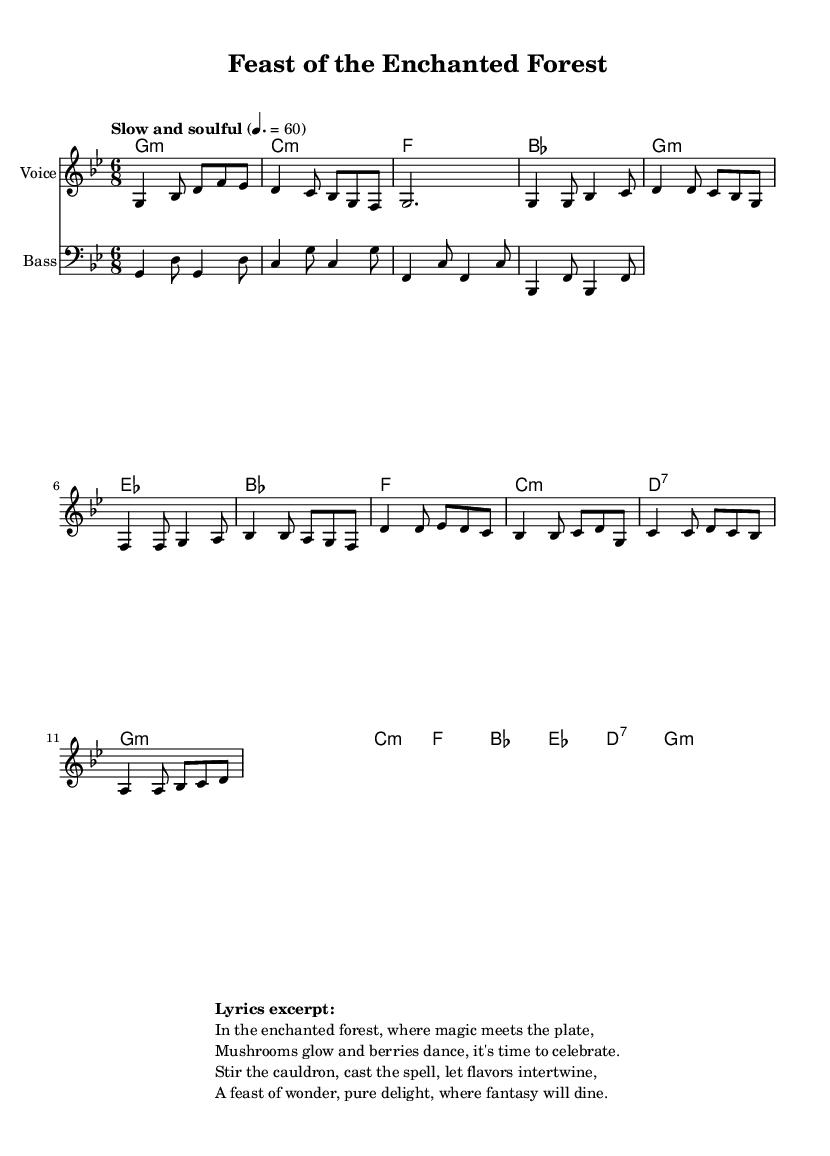What is the key signature of this music? The key signature is G minor, which typically has two flats (B-flat and E-flat) indicated at the beginning of the staff.
Answer: G minor What is the time signature of this music? The time signature is 6/8, as indicated at the beginning of the score, which denotes six eighth notes per measure.
Answer: 6/8 What is the tempo marking for this piece? The tempo marking states "Slow and soulful" with a metronome indication of 60 beats per minute, indicating a slow and smooth performance style.
Answer: Slow and soulful How many main sections can be identified in this ballad? The ballad contains three main sections: the Intro, Verse, and Chorus, as outlined in the structure of the score.
Answer: Three What is the overall theme of the lyrics in this soul ballad? The theme revolves around an enchanted forest where magical feasts take place, celebrating the intertwining of flavors and fantasy.
Answer: Enchanted feast Describe the type of harmony used in this piece during the chorus. The harmony consists predominantly of minor chords with occasional major chords, contributing to the soulful and emotional character of the music.
Answer: Minor chords What emotional quality does the use of G minor provide to this soul ballad? G minor typically evokes a melancholic and introspective emotion, lending depth and soulfulness to the narrative of the ballad.
Answer: Melancholic 